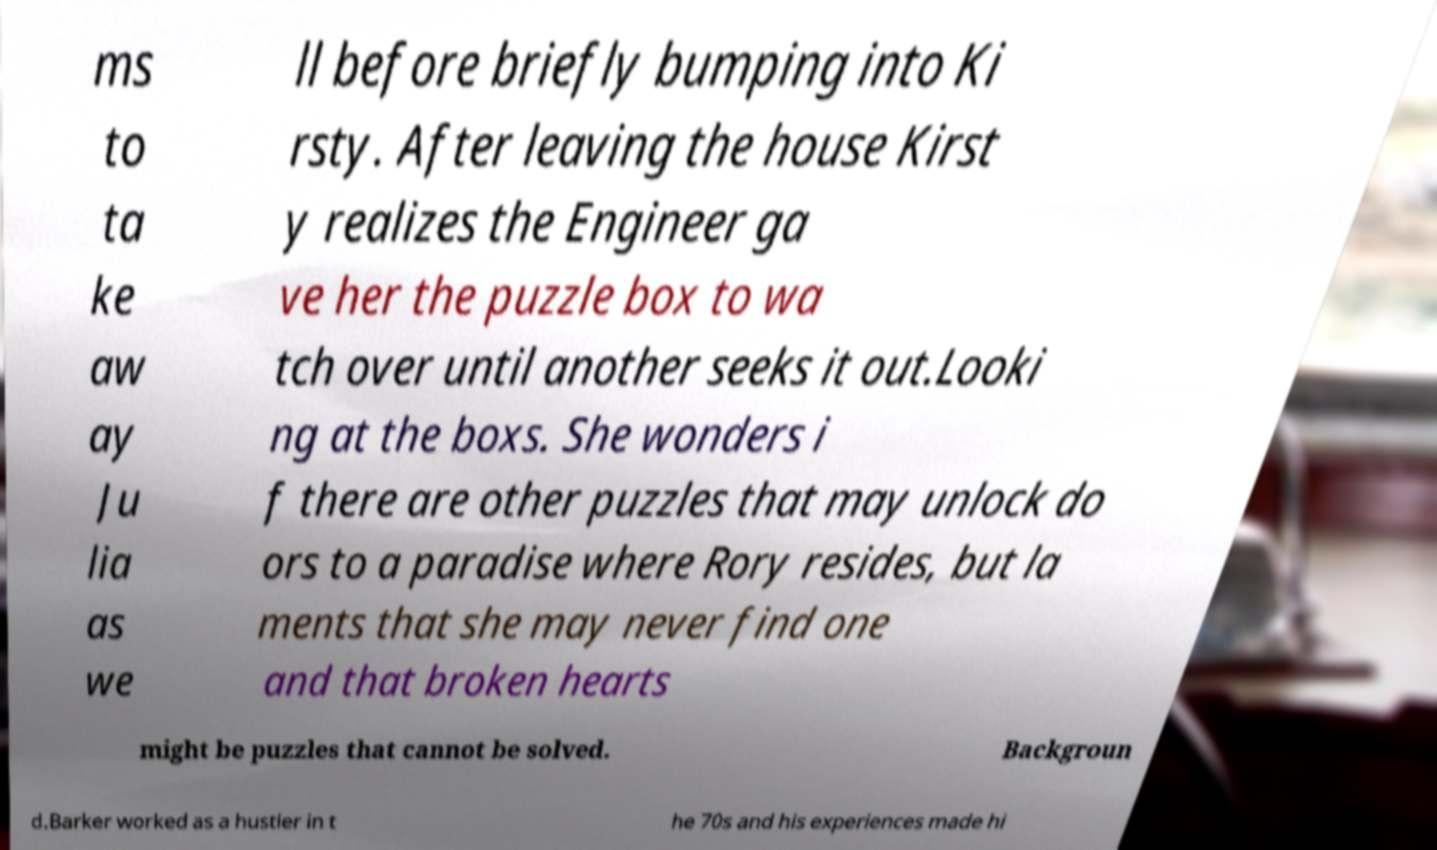What messages or text are displayed in this image? I need them in a readable, typed format. ms to ta ke aw ay Ju lia as we ll before briefly bumping into Ki rsty. After leaving the house Kirst y realizes the Engineer ga ve her the puzzle box to wa tch over until another seeks it out.Looki ng at the boxs. She wonders i f there are other puzzles that may unlock do ors to a paradise where Rory resides, but la ments that she may never find one and that broken hearts might be puzzles that cannot be solved. Backgroun d.Barker worked as a hustler in t he 70s and his experiences made hi 